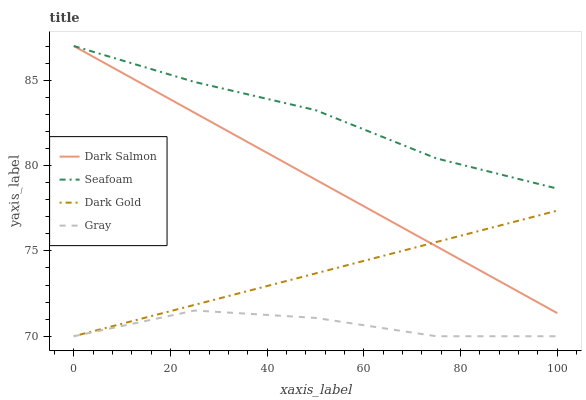Does Gray have the minimum area under the curve?
Answer yes or no. Yes. Does Seafoam have the maximum area under the curve?
Answer yes or no. Yes. Does Dark Gold have the minimum area under the curve?
Answer yes or no. No. Does Dark Gold have the maximum area under the curve?
Answer yes or no. No. Is Dark Gold the smoothest?
Answer yes or no. Yes. Is Gray the roughest?
Answer yes or no. Yes. Is Dark Salmon the smoothest?
Answer yes or no. No. Is Dark Salmon the roughest?
Answer yes or no. No. Does Gray have the lowest value?
Answer yes or no. Yes. Does Dark Salmon have the lowest value?
Answer yes or no. No. Does Seafoam have the highest value?
Answer yes or no. Yes. Does Dark Gold have the highest value?
Answer yes or no. No. Is Gray less than Dark Salmon?
Answer yes or no. Yes. Is Dark Salmon greater than Gray?
Answer yes or no. Yes. Does Seafoam intersect Dark Salmon?
Answer yes or no. Yes. Is Seafoam less than Dark Salmon?
Answer yes or no. No. Is Seafoam greater than Dark Salmon?
Answer yes or no. No. Does Gray intersect Dark Salmon?
Answer yes or no. No. 